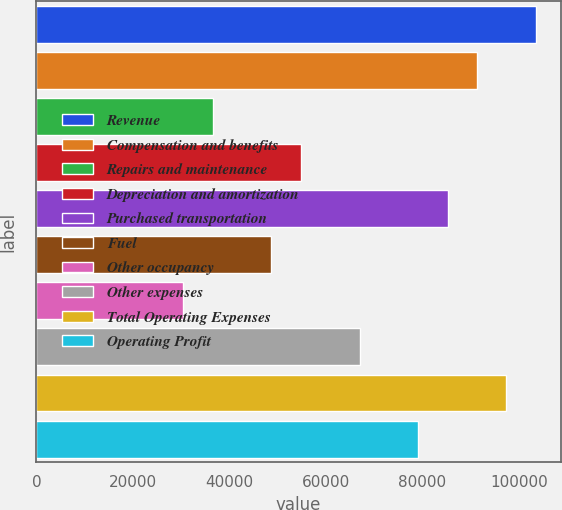Convert chart to OTSL. <chart><loc_0><loc_0><loc_500><loc_500><bar_chart><fcel>Revenue<fcel>Compensation and benefits<fcel>Repairs and maintenance<fcel>Depreciation and amortization<fcel>Purchased transportation<fcel>Fuel<fcel>Other occupancy<fcel>Other expenses<fcel>Total Operating Expenses<fcel>Operating Profit<nl><fcel>103537<fcel>91357<fcel>36545.1<fcel>54815.8<fcel>85266.8<fcel>48725.6<fcel>30454.9<fcel>66996.2<fcel>97447.2<fcel>79176.6<nl></chart> 